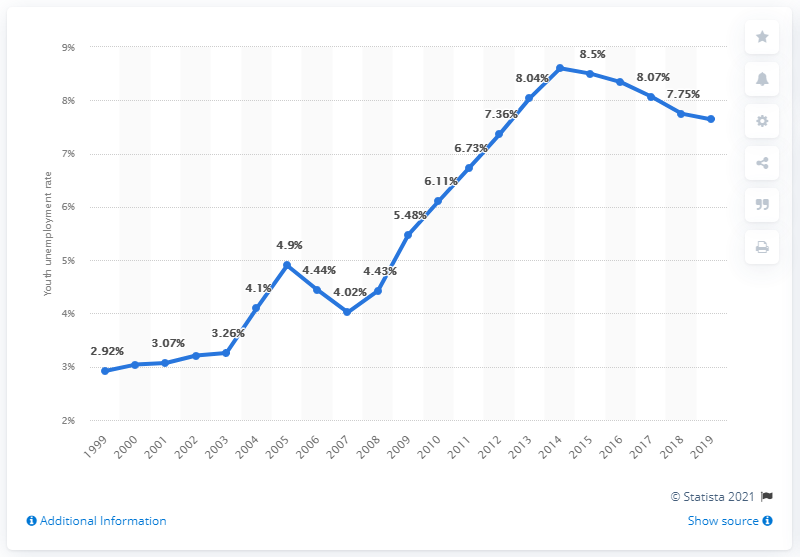Draw attention to some important aspects in this diagram. In 2019, the youth unemployment rate in Burkina Faso was 7.64%. 